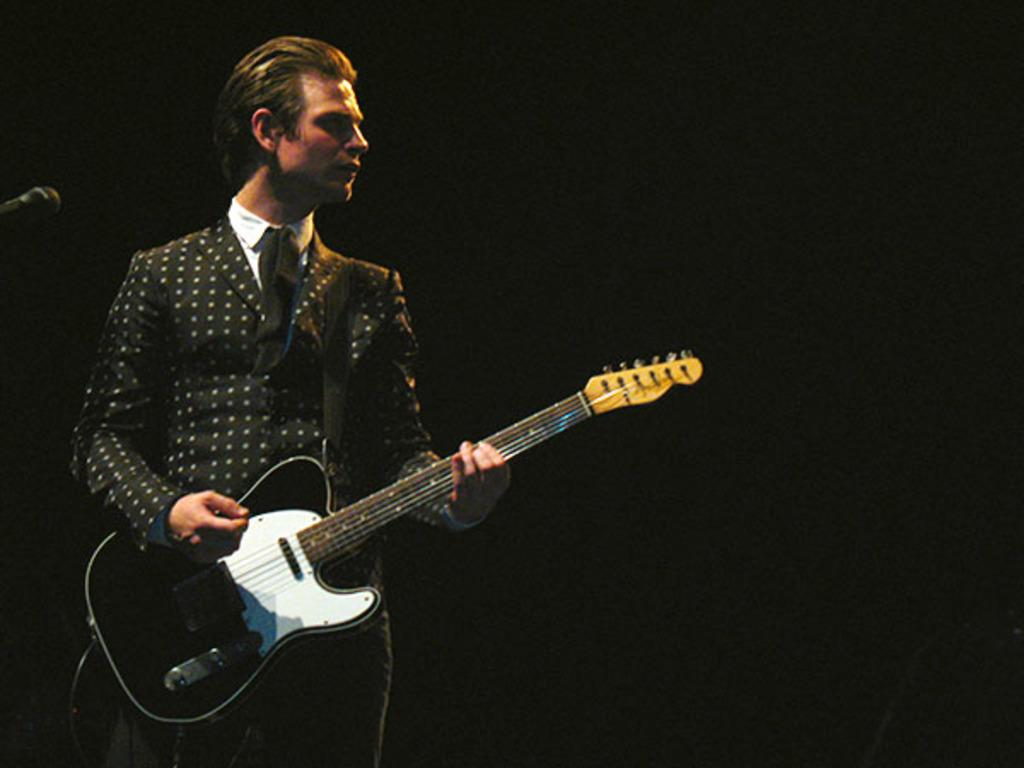What is the man in the image doing? The man is standing in the image and holding a microphone. Is there anything else in front of the man? Yes, there is a microphone in front of the man. What type of banana is the man holding in the image? There is no banana present in the image; the man is holding a microphone. Can you describe the doll that is sitting next to the man in the image? There is no doll present in the image; the man is the only person visible. 